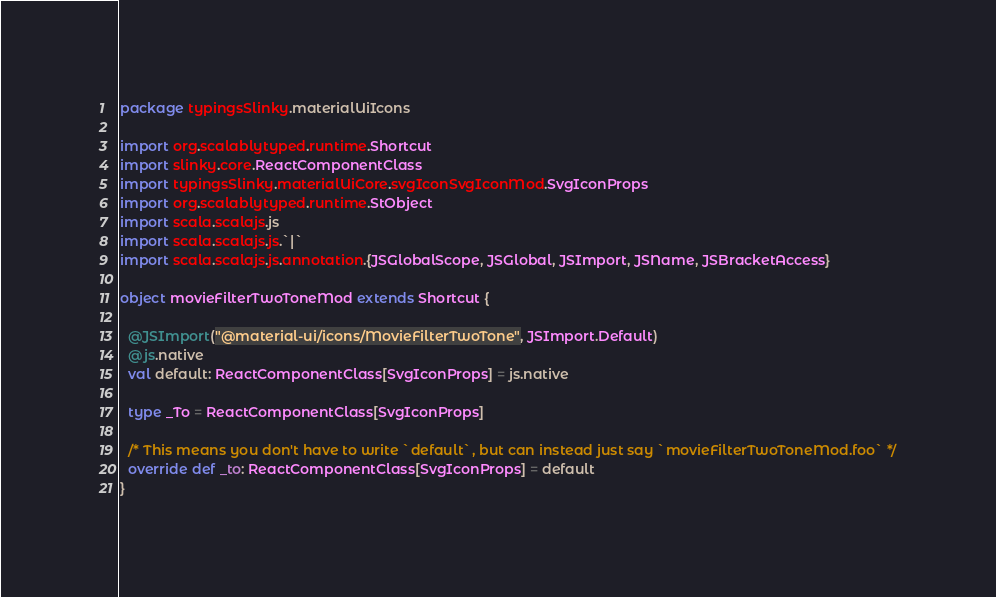Convert code to text. <code><loc_0><loc_0><loc_500><loc_500><_Scala_>package typingsSlinky.materialUiIcons

import org.scalablytyped.runtime.Shortcut
import slinky.core.ReactComponentClass
import typingsSlinky.materialUiCore.svgIconSvgIconMod.SvgIconProps
import org.scalablytyped.runtime.StObject
import scala.scalajs.js
import scala.scalajs.js.`|`
import scala.scalajs.js.annotation.{JSGlobalScope, JSGlobal, JSImport, JSName, JSBracketAccess}

object movieFilterTwoToneMod extends Shortcut {
  
  @JSImport("@material-ui/icons/MovieFilterTwoTone", JSImport.Default)
  @js.native
  val default: ReactComponentClass[SvgIconProps] = js.native
  
  type _To = ReactComponentClass[SvgIconProps]
  
  /* This means you don't have to write `default`, but can instead just say `movieFilterTwoToneMod.foo` */
  override def _to: ReactComponentClass[SvgIconProps] = default
}
</code> 